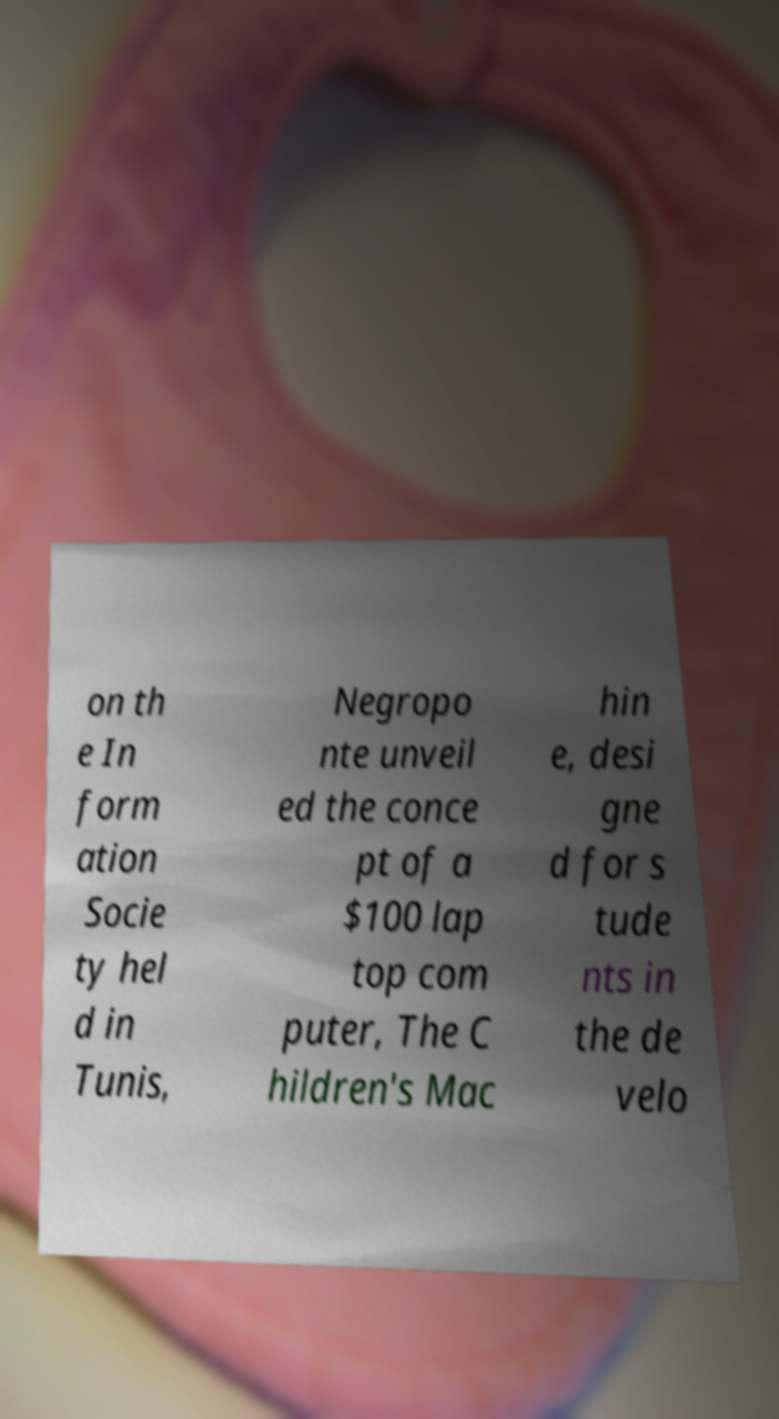What messages or text are displayed in this image? I need them in a readable, typed format. on th e In form ation Socie ty hel d in Tunis, Negropo nte unveil ed the conce pt of a $100 lap top com puter, The C hildren's Mac hin e, desi gne d for s tude nts in the de velo 